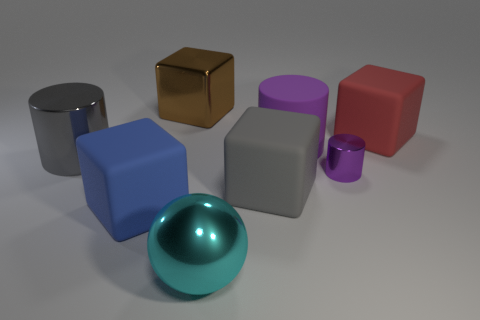What is the material of the brown object that is the same shape as the big blue object?
Offer a very short reply. Metal. How many balls are red objects or gray metallic objects?
Ensure brevity in your answer.  0. Do the rubber cube behind the large gray metal cylinder and the cylinder that is on the left side of the brown metal block have the same size?
Make the answer very short. Yes. There is a large gray object that is behind the gray object right of the cyan metal ball; what is it made of?
Give a very brief answer. Metal. Are there fewer gray blocks that are on the left side of the large brown shiny thing than tiny blue shiny cylinders?
Provide a succinct answer. No. There is a brown object that is the same material as the big sphere; what shape is it?
Ensure brevity in your answer.  Cube. What number of other things are the same shape as the blue object?
Your answer should be very brief. 3. How many purple objects are large metallic cubes or matte cylinders?
Your response must be concise. 1. Is the blue thing the same shape as the gray matte thing?
Keep it short and to the point. Yes. There is a large gray object behind the purple metal cylinder; are there any brown metal things behind it?
Offer a terse response. Yes. 